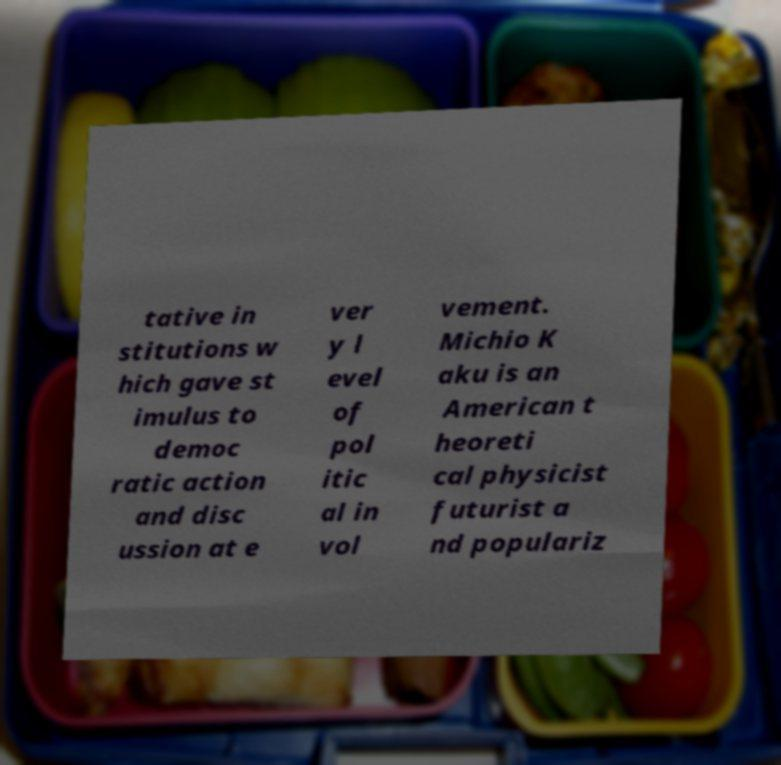Can you read and provide the text displayed in the image?This photo seems to have some interesting text. Can you extract and type it out for me? tative in stitutions w hich gave st imulus to democ ratic action and disc ussion at e ver y l evel of pol itic al in vol vement. Michio K aku is an American t heoreti cal physicist futurist a nd populariz 